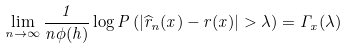Convert formula to latex. <formula><loc_0><loc_0><loc_500><loc_500>\lim _ { n \rightarrow \infty } \frac { 1 } { n \phi ( h ) } \log P \left ( | \widehat { r } _ { n } ( x ) - r ( x ) | > \lambda \right ) = \Gamma _ { x } ( \lambda )</formula> 